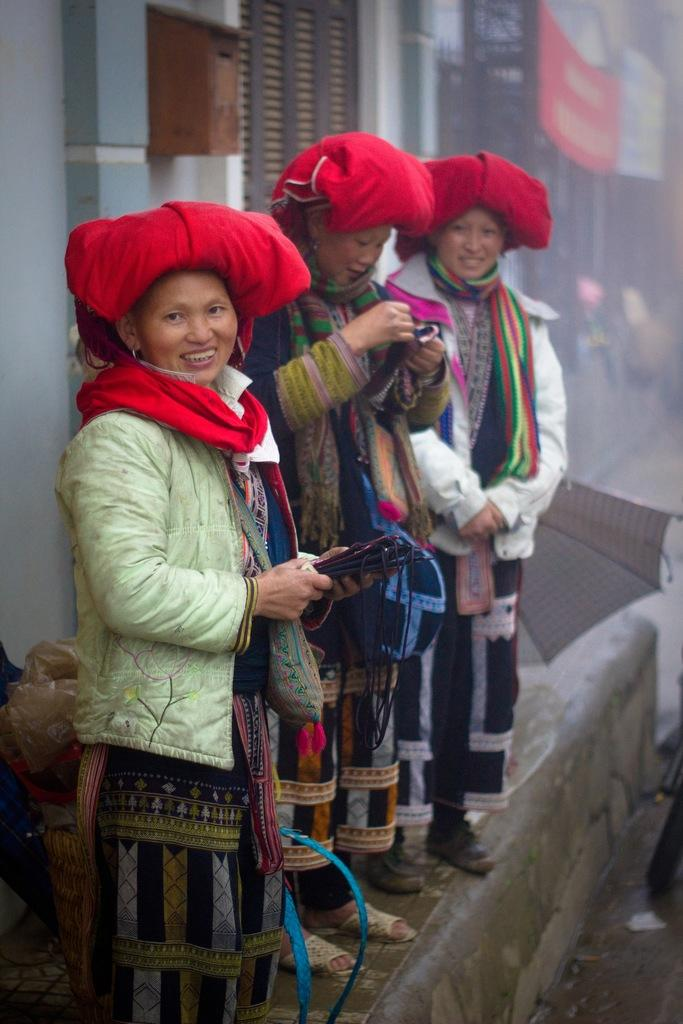What is happening in the image? There are people standing in the image. Can you describe what the two women are holding? Two women are holding something, but the facts do not specify what they are holding. What can be seen in the background of the image? There is a wall, a cover, a letter box, windows, and an umbrella in the background of the image. How many pigs can be seen in the image? There are no pigs present in the image. What type of sorting is happening in the image? There is no sorting activity depicted in the image. 